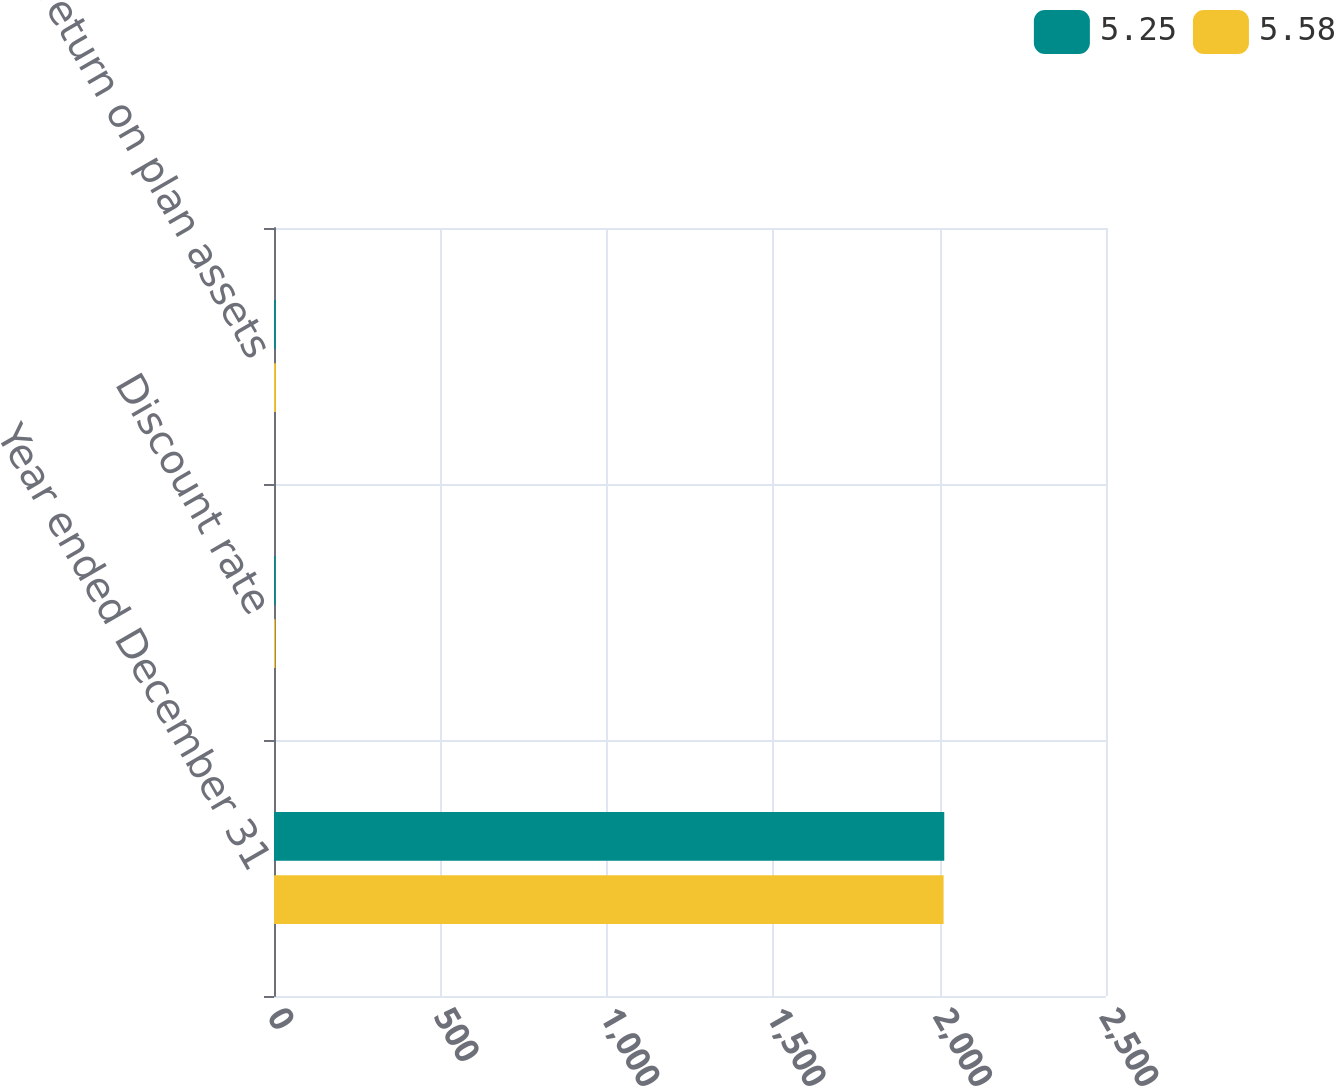Convert chart to OTSL. <chart><loc_0><loc_0><loc_500><loc_500><stacked_bar_chart><ecel><fcel>Year ended December 31<fcel>Discount rate<fcel>Expected return on plan assets<nl><fcel>5.25<fcel>2014<fcel>4.5<fcel>5.25<nl><fcel>5.58<fcel>2012<fcel>4<fcel>5.58<nl></chart> 